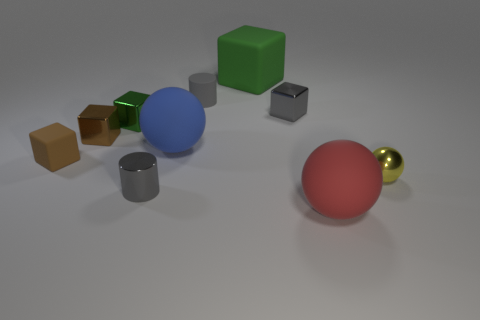There is a green metal thing; what number of tiny gray things are in front of it?
Your answer should be compact. 1. The large matte ball that is to the left of the gray rubber thing is what color?
Your response must be concise. Blue. There is a small shiny thing that is the same shape as the blue rubber object; what is its color?
Provide a short and direct response. Yellow. Is there any other thing of the same color as the rubber cylinder?
Provide a succinct answer. Yes. Is the number of small red cylinders greater than the number of blue things?
Your answer should be very brief. No. Are the tiny green thing and the tiny gray block made of the same material?
Your response must be concise. Yes. What number of large balls are made of the same material as the red object?
Your answer should be compact. 1. Does the brown rubber cube have the same size as the ball that is left of the big green object?
Ensure brevity in your answer.  No. What is the color of the matte object that is both behind the yellow ball and in front of the big blue rubber ball?
Make the answer very short. Brown. Is there a small green cube on the left side of the small matte block behind the small yellow thing?
Your answer should be very brief. No. 